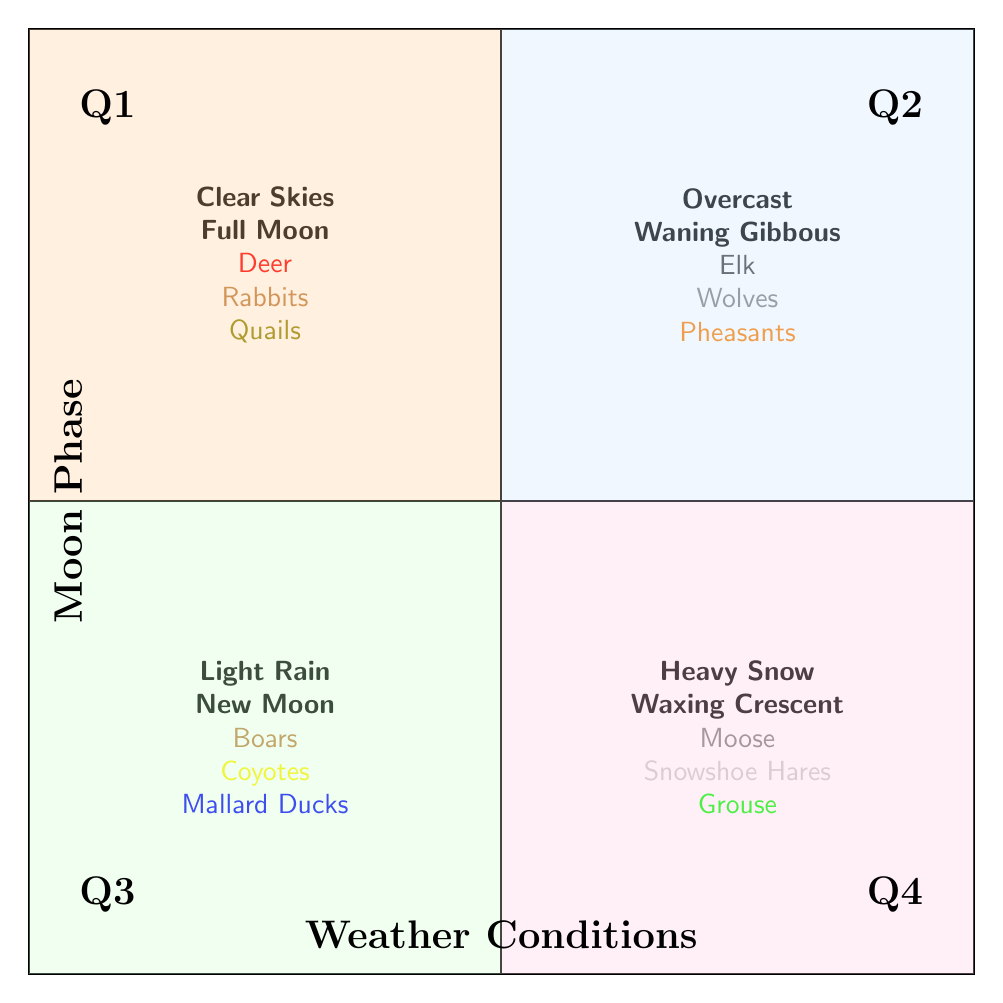What animals are optimal to hunt during clear skies and a full moon? The top left quadrant (Q1) indicates that during "Clear Skies" and "Full Moon," the optimal animals are "Deer," "Rabbits," and "Quails."
Answer: Deer, Rabbits, Quails Which quadrant features light rain and a new moon? The bottom left quadrant (Q3) represents "Light Rain" and "New Moon."
Answer: Q3 What is the weather condition corresponding to the optimum hunting of elk? The top right quadrant (Q2) shows that "Overcast" is the weather condition where elk are optimal to hunt.
Answer: Overcast How many different animals are listed in quadrant Q4? Quadrant Q4 mentions three animals: "Moose," "Snowshoe Hares," and "Grouse," indicating a total of three animals.
Answer: 3 Which moon phase is associated with hunting during heavy snow? The bottom right quadrant (Q4) shows that "Waxing Crescent" is the moon phase associated with heavy snow hunting conditions.
Answer: Waxing Crescent What are the optimal hunting conditions for boars? In the bottom left quadrant (Q3), it is stated that "Light Rain" and "New Moon" are the hunting conditions optimal for boars.
Answer: Light Rain, New Moon Is there any overlap in optimal animals between quadrants Q1 and Q2? By analyzing Q1 and Q2, it’s clear that each quadrant lists different animals: Q1 lists "Deer," "Rabbits," and "Quails," while Q2 lists "Elk," "Wolves," and "Pheasants," confirming no overlap.
Answer: No overlap Which quadrant would you consult for hunting under heavy snow conditions? The bottom right quadrant (Q4) is the designated area for "Heavy Snow" conditions that are optimal for hunting.
Answer: Q4 